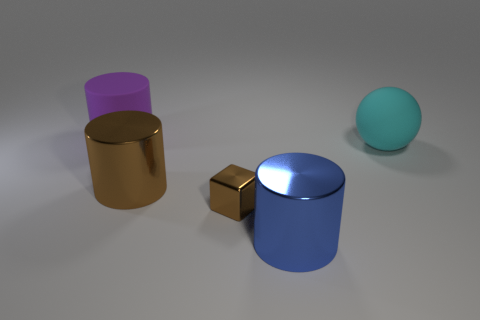Subtract all big blue metallic cylinders. How many cylinders are left? 2 Add 2 yellow matte cubes. How many objects exist? 7 Subtract all cubes. How many objects are left? 4 Subtract 1 cylinders. How many cylinders are left? 2 Subtract all blue cylinders. How many cylinders are left? 2 Add 4 big purple matte cylinders. How many big purple matte cylinders are left? 5 Add 3 cyan things. How many cyan things exist? 4 Subtract 0 yellow cubes. How many objects are left? 5 Subtract all gray blocks. Subtract all red cylinders. How many blocks are left? 1 Subtract all purple spheres. How many blue cylinders are left? 1 